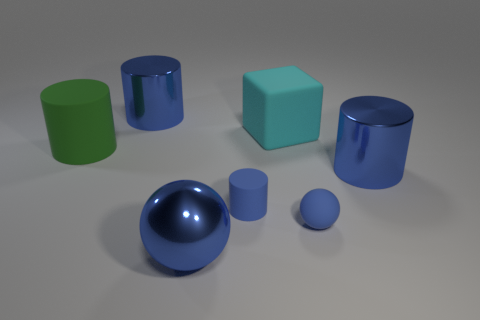Subtract all blue spheres. How many blue cylinders are left? 3 Add 2 cylinders. How many objects exist? 9 Subtract all spheres. How many objects are left? 5 Add 7 small blue cylinders. How many small blue cylinders are left? 8 Add 7 tiny blue cylinders. How many tiny blue cylinders exist? 8 Subtract 0 yellow cubes. How many objects are left? 7 Subtract all gray cubes. Subtract all rubber spheres. How many objects are left? 6 